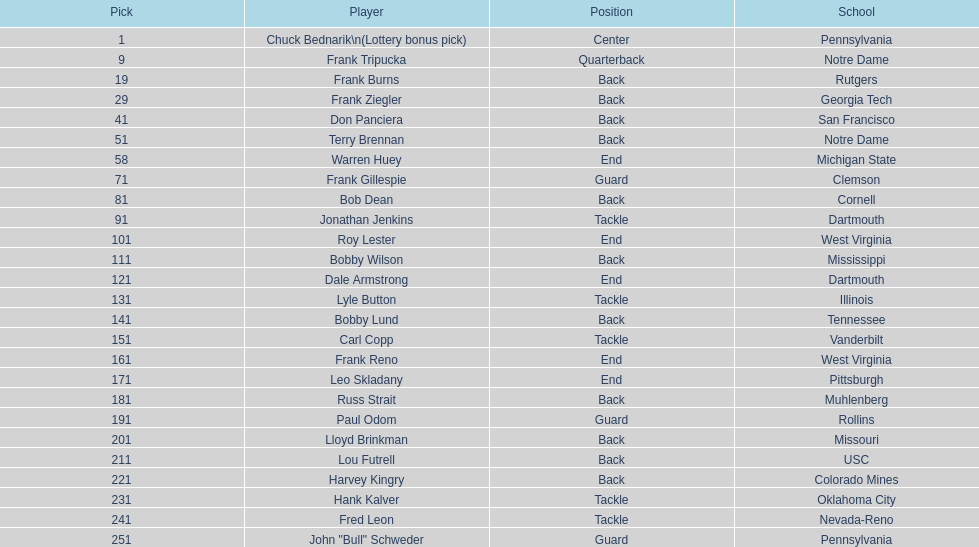Who holds a similar role as frank gillespie? Paul Odom, John "Bull" Schweder. 